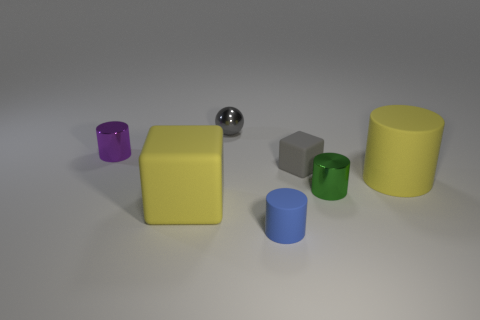There is a green cylinder in front of the yellow cylinder; does it have the same size as the small purple shiny object?
Provide a succinct answer. Yes. What color is the rubber cube behind the shiny thing in front of the tiny metal cylinder that is behind the tiny gray block?
Make the answer very short. Gray. The big cylinder has what color?
Keep it short and to the point. Yellow. Is the sphere the same color as the tiny matte cylinder?
Make the answer very short. No. Do the big thing right of the tiny blue rubber cylinder and the big yellow thing that is to the left of the big yellow rubber cylinder have the same material?
Offer a terse response. Yes. There is a tiny purple thing that is the same shape as the blue thing; what material is it?
Your response must be concise. Metal. Does the blue cylinder have the same material as the big yellow cube?
Your response must be concise. Yes. There is a metal cylinder that is behind the block that is behind the big yellow block; what is its color?
Your response must be concise. Purple. There is a gray cube that is made of the same material as the big yellow cube; what size is it?
Your response must be concise. Small. How many green things are the same shape as the purple object?
Your answer should be very brief. 1. 